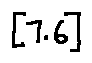Convert formula to latex. <formula><loc_0><loc_0><loc_500><loc_500>[ 7 . 6 ]</formula> 